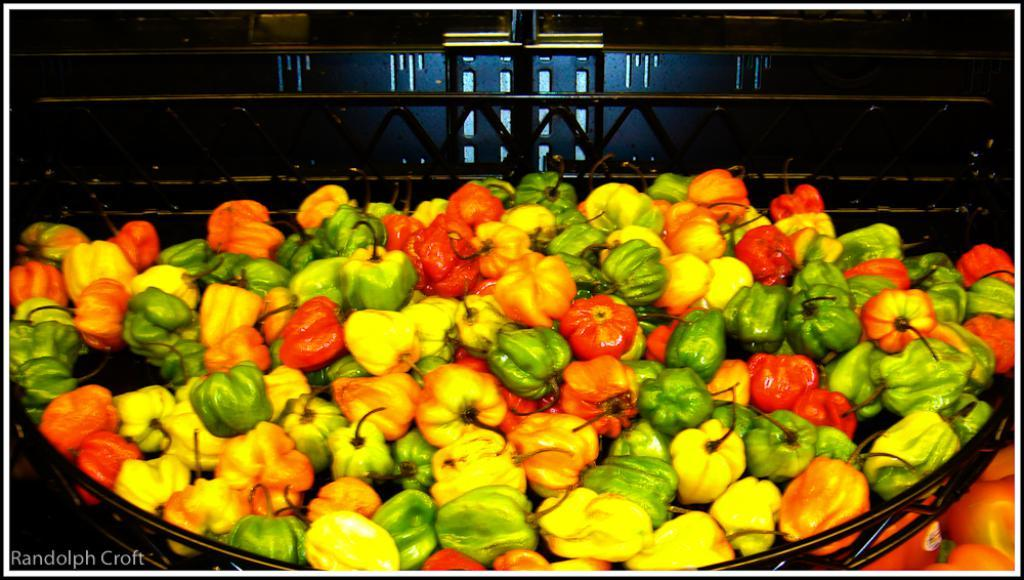What type of food items are present in the image? There are many capsicums of different colors in the image. What type of barrier can be seen in the image? There is a metal fence in the image. Is there any text or logo visible in the image? Yes, there is a watermark in the bottom left corner of the image. How many spiders are crawling on the capsicums in the image? There are no spiders present in the image; it only features capsicums and a metal fence. 